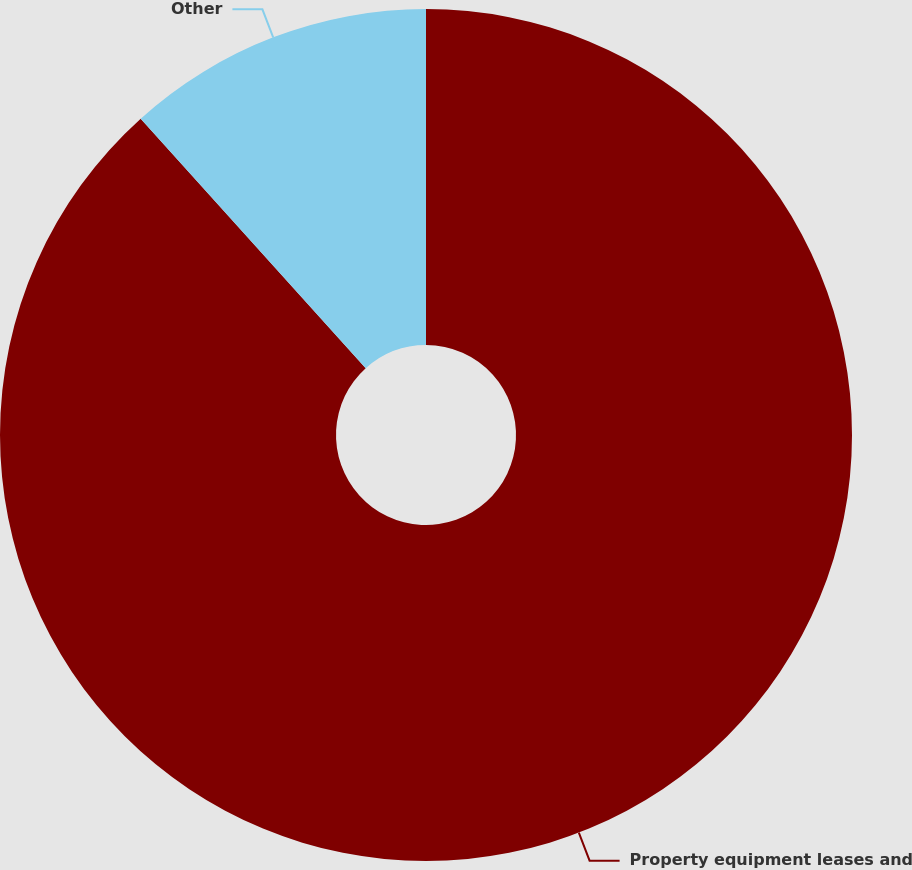Convert chart to OTSL. <chart><loc_0><loc_0><loc_500><loc_500><pie_chart><fcel>Property equipment leases and<fcel>Other<nl><fcel>88.32%<fcel>11.68%<nl></chart> 